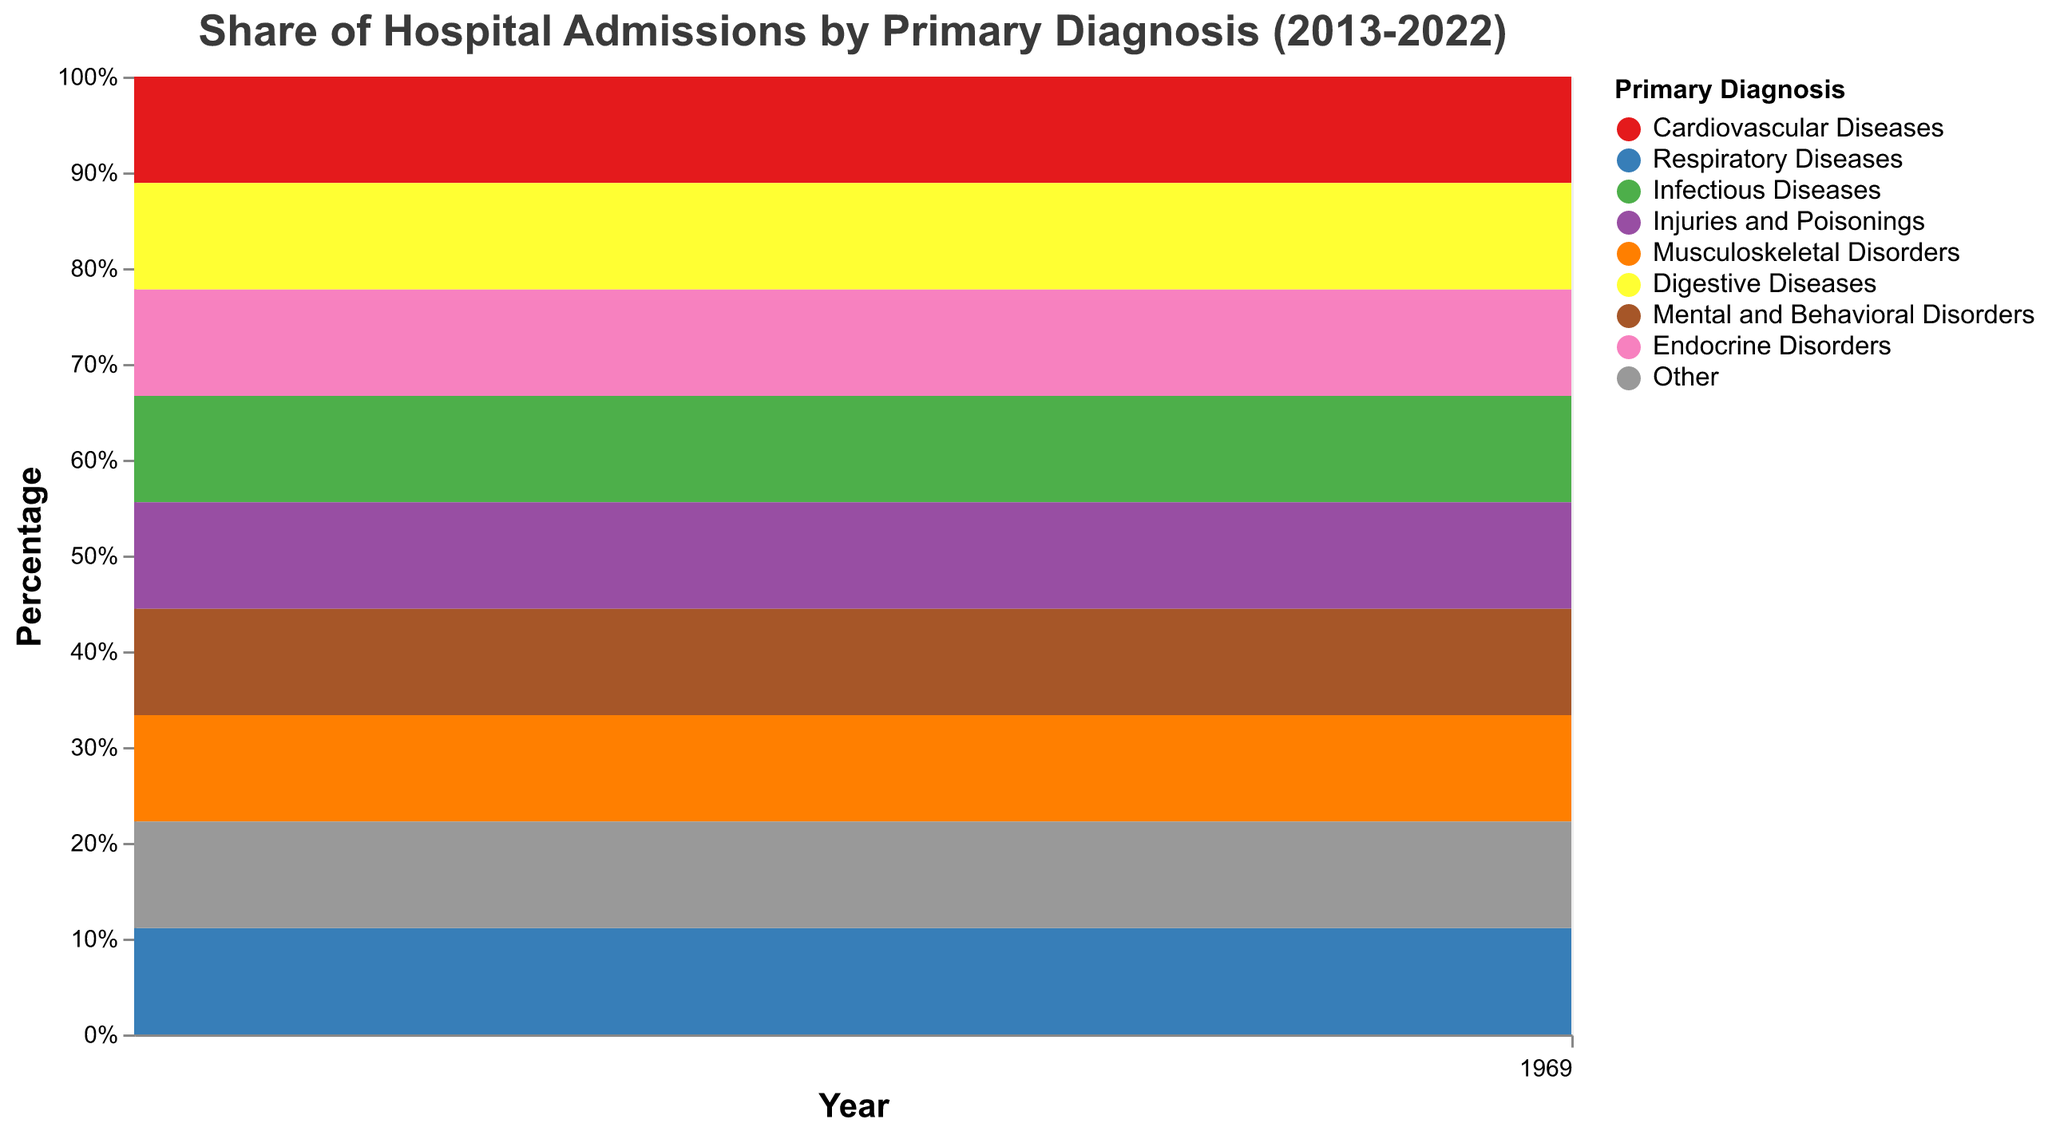What is the title of the chart? Look at the top of the chart where the title is displayed.
Answer: Share of Hospital Admissions by Primary Diagnosis (2013-2022) Which primary diagnosis had the highest percentage of hospital admissions in 2013? Identify the area segment with the largest height in the stacked area corresponding to 2013.
Answer: Respiratory Diseases Has the share of hospital admissions for Infectious Diseases increased or decreased from 2013 to 2022? Compare the area height for Infectious Diseases between 2013 and 2022.
Answer: Decreased How does the share of hospital admissions for Musculoskeletal Disorders in 2018 compare to that in 2022? Compare the area segments corresponding to Musculoskeletal Disorders in 2018 and 2022.
Answer: Higher in 2018 In which year did Respiratory Diseases almost reach the same share of hospital admissions as Cardiovascular Diseases? Look at the years where the gap between Respiratory Diseases and Cardiovascular Diseases is minimal.
Answer: 2019 What is the trend in the share of hospital admissions for Mental and Behavioral Disorders between 2013 and 2022? Observe the relative area size for Mental and Behavioral Disorders over the years.
Answer: Increasing Which primary diagnosis shows the most significant variability in hospital admission share over the years? Analyze the fluctuations in the area size for each primary diagnosis throughout the chart.
Answer: Respiratory Diseases What was the total percentage for Other primary diagnosis in 2015? Sum up all the diagnosis's shares by ensuring the “Other” share based on the stacking principle.
Answer: About 6% In the ten-year period, which year had the lowest share for Endocrine Disorders? Identify the year where the area segment for Endocrine Disorders is the smallest.
Answer: 2021 By looking at the chart, which primary diagnosis had a consistent share of around 10% over the years? Identify the diagnosis area that remains relatively stable around 10% throughout the period.
Answer: Injuries and Poisonings 